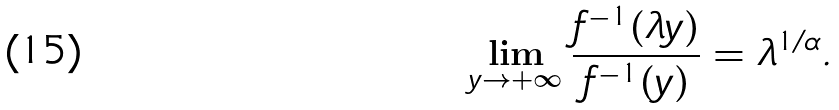<formula> <loc_0><loc_0><loc_500><loc_500>\lim _ { y \to + \infty } \frac { f ^ { - 1 } ( \lambda y ) } { f ^ { - 1 } ( y ) } = \lambda ^ { 1 / \alpha } .</formula> 